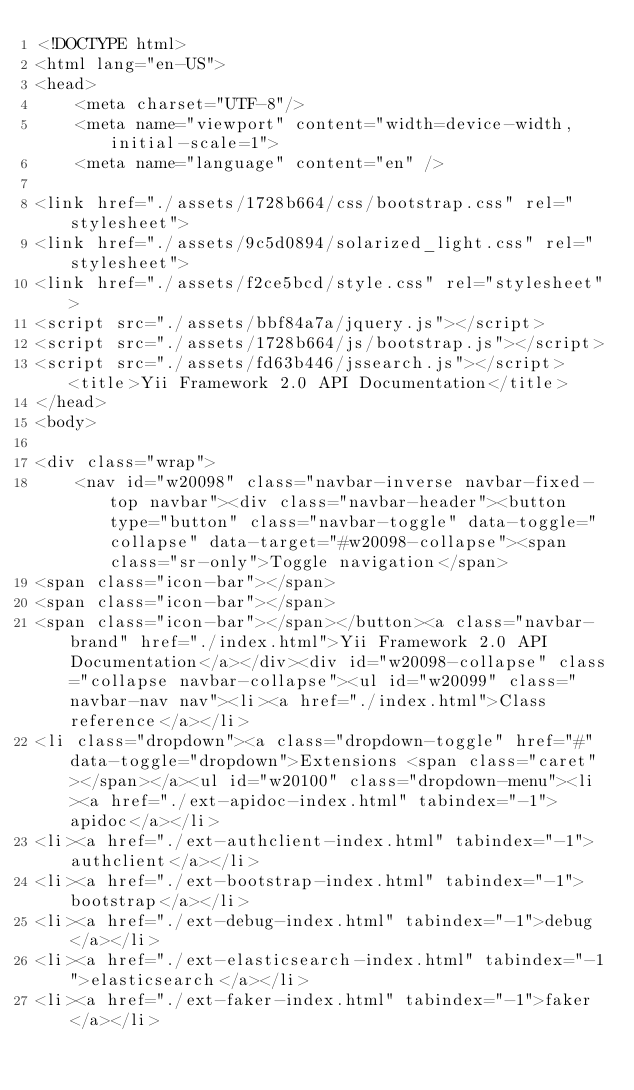Convert code to text. <code><loc_0><loc_0><loc_500><loc_500><_HTML_><!DOCTYPE html>
<html lang="en-US">
<head>
    <meta charset="UTF-8"/>
    <meta name="viewport" content="width=device-width, initial-scale=1">
    <meta name="language" content="en" />
        
<link href="./assets/1728b664/css/bootstrap.css" rel="stylesheet">
<link href="./assets/9c5d0894/solarized_light.css" rel="stylesheet">
<link href="./assets/f2ce5bcd/style.css" rel="stylesheet">
<script src="./assets/bbf84a7a/jquery.js"></script>
<script src="./assets/1728b664/js/bootstrap.js"></script>
<script src="./assets/fd63b446/jssearch.js"></script>    <title>Yii Framework 2.0 API Documentation</title>
</head>
<body>

<div class="wrap">
    <nav id="w20098" class="navbar-inverse navbar-fixed-top navbar"><div class="navbar-header"><button type="button" class="navbar-toggle" data-toggle="collapse" data-target="#w20098-collapse"><span class="sr-only">Toggle navigation</span>
<span class="icon-bar"></span>
<span class="icon-bar"></span>
<span class="icon-bar"></span></button><a class="navbar-brand" href="./index.html">Yii Framework 2.0 API Documentation</a></div><div id="w20098-collapse" class="collapse navbar-collapse"><ul id="w20099" class="navbar-nav nav"><li><a href="./index.html">Class reference</a></li>
<li class="dropdown"><a class="dropdown-toggle" href="#" data-toggle="dropdown">Extensions <span class="caret"></span></a><ul id="w20100" class="dropdown-menu"><li><a href="./ext-apidoc-index.html" tabindex="-1">apidoc</a></li>
<li><a href="./ext-authclient-index.html" tabindex="-1">authclient</a></li>
<li><a href="./ext-bootstrap-index.html" tabindex="-1">bootstrap</a></li>
<li><a href="./ext-debug-index.html" tabindex="-1">debug</a></li>
<li><a href="./ext-elasticsearch-index.html" tabindex="-1">elasticsearch</a></li>
<li><a href="./ext-faker-index.html" tabindex="-1">faker</a></li></code> 